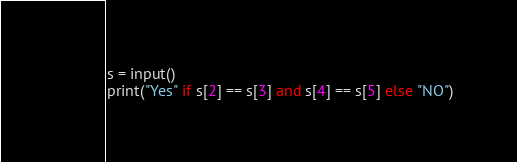Convert code to text. <code><loc_0><loc_0><loc_500><loc_500><_Python_>s = input()
print("Yes" if s[2] == s[3] and s[4] == s[5] else "NO")</code> 